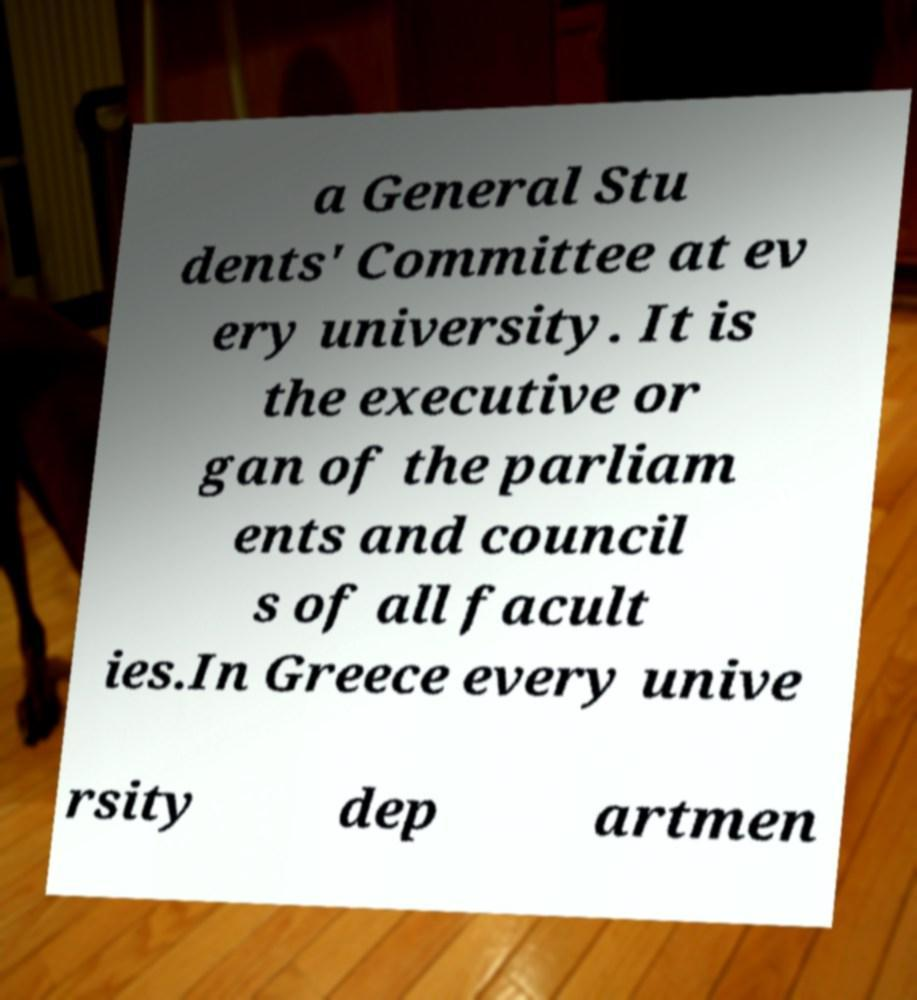For documentation purposes, I need the text within this image transcribed. Could you provide that? a General Stu dents' Committee at ev ery university. It is the executive or gan of the parliam ents and council s of all facult ies.In Greece every unive rsity dep artmen 